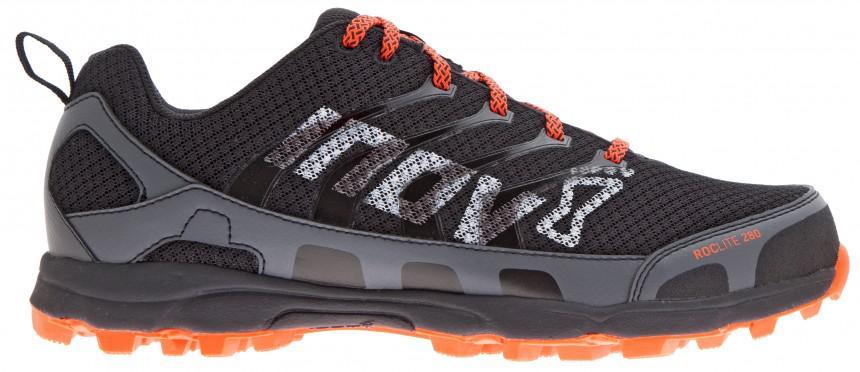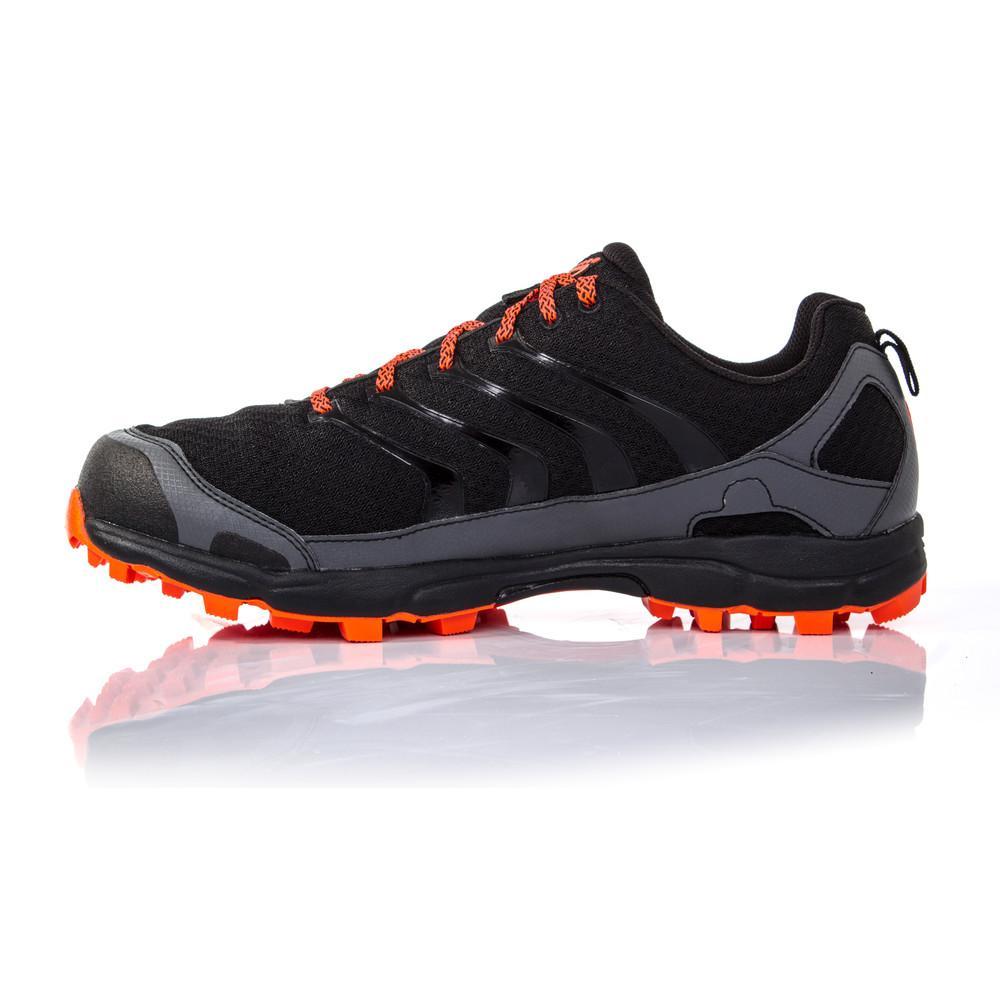The first image is the image on the left, the second image is the image on the right. Evaluate the accuracy of this statement regarding the images: "The left image contains one leftward angled sneaker, and the right image contains a pair of sneakers posed side-by-side heel-to-toe.". Is it true? Answer yes or no. No. The first image is the image on the left, the second image is the image on the right. Evaluate the accuracy of this statement regarding the images: "In one image, a pair of shoes has one shoe facing forward and one facing backward, the color of the shoe soles matching the inside fabric.". Is it true? Answer yes or no. No. 